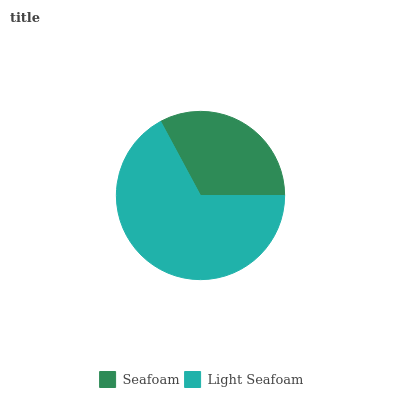Is Seafoam the minimum?
Answer yes or no. Yes. Is Light Seafoam the maximum?
Answer yes or no. Yes. Is Light Seafoam the minimum?
Answer yes or no. No. Is Light Seafoam greater than Seafoam?
Answer yes or no. Yes. Is Seafoam less than Light Seafoam?
Answer yes or no. Yes. Is Seafoam greater than Light Seafoam?
Answer yes or no. No. Is Light Seafoam less than Seafoam?
Answer yes or no. No. Is Light Seafoam the high median?
Answer yes or no. Yes. Is Seafoam the low median?
Answer yes or no. Yes. Is Seafoam the high median?
Answer yes or no. No. Is Light Seafoam the low median?
Answer yes or no. No. 